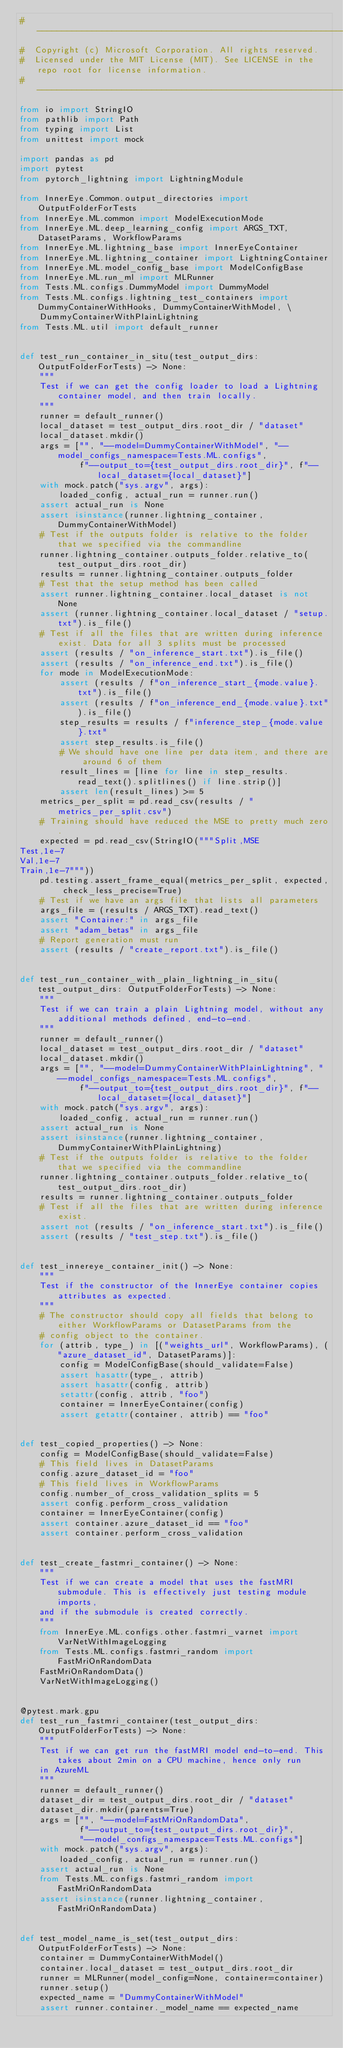Convert code to text. <code><loc_0><loc_0><loc_500><loc_500><_Python_>#  ------------------------------------------------------------------------------------------
#  Copyright (c) Microsoft Corporation. All rights reserved.
#  Licensed under the MIT License (MIT). See LICENSE in the repo root for license information.
#  ------------------------------------------------------------------------------------------
from io import StringIO
from pathlib import Path
from typing import List
from unittest import mock

import pandas as pd
import pytest
from pytorch_lightning import LightningModule

from InnerEye.Common.output_directories import OutputFolderForTests
from InnerEye.ML.common import ModelExecutionMode
from InnerEye.ML.deep_learning_config import ARGS_TXT, DatasetParams, WorkflowParams
from InnerEye.ML.lightning_base import InnerEyeContainer
from InnerEye.ML.lightning_container import LightningContainer
from InnerEye.ML.model_config_base import ModelConfigBase
from InnerEye.ML.run_ml import MLRunner
from Tests.ML.configs.DummyModel import DummyModel
from Tests.ML.configs.lightning_test_containers import DummyContainerWithHooks, DummyContainerWithModel, \
    DummyContainerWithPlainLightning
from Tests.ML.util import default_runner


def test_run_container_in_situ(test_output_dirs: OutputFolderForTests) -> None:
    """
    Test if we can get the config loader to load a Lightning container model, and then train locally.
    """
    runner = default_runner()
    local_dataset = test_output_dirs.root_dir / "dataset"
    local_dataset.mkdir()
    args = ["", "--model=DummyContainerWithModel", "--model_configs_namespace=Tests.ML.configs",
            f"--output_to={test_output_dirs.root_dir}", f"--local_dataset={local_dataset}"]
    with mock.patch("sys.argv", args):
        loaded_config, actual_run = runner.run()
    assert actual_run is None
    assert isinstance(runner.lightning_container, DummyContainerWithModel)
    # Test if the outputs folder is relative to the folder that we specified via the commandline
    runner.lightning_container.outputs_folder.relative_to(test_output_dirs.root_dir)
    results = runner.lightning_container.outputs_folder
    # Test that the setup method has been called
    assert runner.lightning_container.local_dataset is not None
    assert (runner.lightning_container.local_dataset / "setup.txt").is_file()
    # Test if all the files that are written during inference exist. Data for all 3 splits must be processed
    assert (results / "on_inference_start.txt").is_file()
    assert (results / "on_inference_end.txt").is_file()
    for mode in ModelExecutionMode:
        assert (results / f"on_inference_start_{mode.value}.txt").is_file()
        assert (results / f"on_inference_end_{mode.value}.txt").is_file()
        step_results = results / f"inference_step_{mode.value}.txt"
        assert step_results.is_file()
        # We should have one line per data item, and there are around 6 of them
        result_lines = [line for line in step_results.read_text().splitlines() if line.strip()]
        assert len(result_lines) >= 5
    metrics_per_split = pd.read_csv(results / "metrics_per_split.csv")
    # Training should have reduced the MSE to pretty much zero.
    expected = pd.read_csv(StringIO("""Split,MSE
Test,1e-7
Val,1e-7
Train,1e-7"""))
    pd.testing.assert_frame_equal(metrics_per_split, expected, check_less_precise=True)
    # Test if we have an args file that lists all parameters
    args_file = (results / ARGS_TXT).read_text()
    assert "Container:" in args_file
    assert "adam_betas" in args_file
    # Report generation must run
    assert (results / "create_report.txt").is_file()


def test_run_container_with_plain_lightning_in_situ(test_output_dirs: OutputFolderForTests) -> None:
    """
    Test if we can train a plain Lightning model, without any additional methods defined, end-to-end.
    """
    runner = default_runner()
    local_dataset = test_output_dirs.root_dir / "dataset"
    local_dataset.mkdir()
    args = ["", "--model=DummyContainerWithPlainLightning", "--model_configs_namespace=Tests.ML.configs",
            f"--output_to={test_output_dirs.root_dir}", f"--local_dataset={local_dataset}"]
    with mock.patch("sys.argv", args):
        loaded_config, actual_run = runner.run()
    assert actual_run is None
    assert isinstance(runner.lightning_container, DummyContainerWithPlainLightning)
    # Test if the outputs folder is relative to the folder that we specified via the commandline
    runner.lightning_container.outputs_folder.relative_to(test_output_dirs.root_dir)
    results = runner.lightning_container.outputs_folder
    # Test if all the files that are written during inference exist.
    assert not (results / "on_inference_start.txt").is_file()
    assert (results / "test_step.txt").is_file()


def test_innereye_container_init() -> None:
    """
    Test if the constructor of the InnerEye container copies attributes as expected.
    """
    # The constructor should copy all fields that belong to either WorkflowParams or DatasetParams from the
    # config object to the container.
    for (attrib, type_) in [("weights_url", WorkflowParams), ("azure_dataset_id", DatasetParams)]:
        config = ModelConfigBase(should_validate=False)
        assert hasattr(type_, attrib)
        assert hasattr(config, attrib)
        setattr(config, attrib, "foo")
        container = InnerEyeContainer(config)
        assert getattr(container, attrib) == "foo"


def test_copied_properties() -> None:
    config = ModelConfigBase(should_validate=False)
    # This field lives in DatasetParams
    config.azure_dataset_id = "foo"
    # This field lives in WorkflowParams
    config.number_of_cross_validation_splits = 5
    assert config.perform_cross_validation
    container = InnerEyeContainer(config)
    assert container.azure_dataset_id == "foo"
    assert container.perform_cross_validation


def test_create_fastmri_container() -> None:
    """
    Test if we can create a model that uses the fastMRI submodule. This is effectively just testing module imports,
    and if the submodule is created correctly.
    """
    from InnerEye.ML.configs.other.fastmri_varnet import VarNetWithImageLogging
    from Tests.ML.configs.fastmri_random import FastMriOnRandomData
    FastMriOnRandomData()
    VarNetWithImageLogging()


@pytest.mark.gpu
def test_run_fastmri_container(test_output_dirs: OutputFolderForTests) -> None:
    """
    Test if we can get run the fastMRI model end-to-end. This takes about 2min on a CPU machine, hence only run
    in AzureML
    """
    runner = default_runner()
    dataset_dir = test_output_dirs.root_dir / "dataset"
    dataset_dir.mkdir(parents=True)
    args = ["", "--model=FastMriOnRandomData",
            f"--output_to={test_output_dirs.root_dir}",
            "--model_configs_namespace=Tests.ML.configs"]
    with mock.patch("sys.argv", args):
        loaded_config, actual_run = runner.run()
    assert actual_run is None
    from Tests.ML.configs.fastmri_random import FastMriOnRandomData
    assert isinstance(runner.lightning_container, FastMriOnRandomData)


def test_model_name_is_set(test_output_dirs: OutputFolderForTests) -> None:
    container = DummyContainerWithModel()
    container.local_dataset = test_output_dirs.root_dir
    runner = MLRunner(model_config=None, container=container)
    runner.setup()
    expected_name = "DummyContainerWithModel"
    assert runner.container._model_name == expected_name</code> 